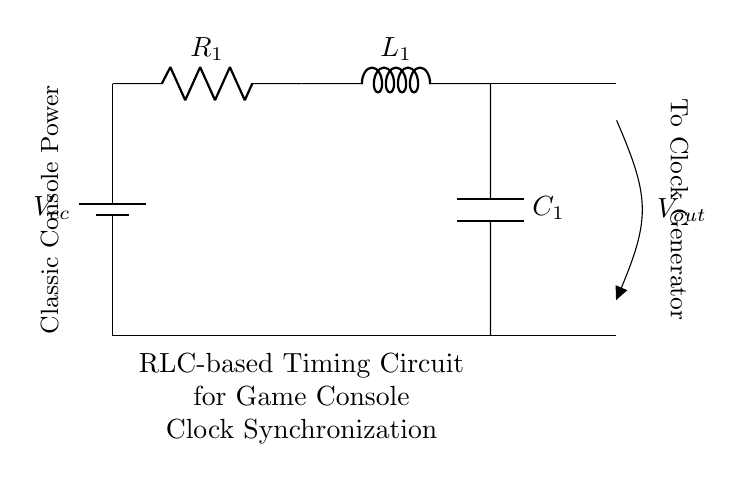What are the components in this circuit? The circuit includes a battery, a resistor, an inductor, and a capacitor, as indicated by the symbols and labels in the diagram.
Answer: battery, resistor, inductor, capacitor What is the value of R1? The value of R1 is not specified in the diagram, so it remains unspecified based on the visual information provided.
Answer: unspecified What is the purpose of the inductor in this circuit? The inductor stores energy in a magnetic field when current flows through it and can influence timing in RLC circuits, contributing to the clock synchronization functionality.
Answer: energy storage What does Vout represent in the circuit? Vout is the output voltage taken across the capacitor, which is essential for clock synchronization in this RLC timing circuit design.
Answer: output voltage What is the relationship between R, L, and C in this timing circuit? In an RLC circuit, R, L, and C work together to determine the time constant and oscillation frequency, which affect how the circuit operates to achieve clock synchronization.
Answer: time constant and frequency What type of circuit is this? This circuit is identified as an RLC circuit since it contains a resistor, an inductor, and a capacitor, specifically arranged for timing functions.
Answer: RLC circuit How does this circuit benefit classic game consoles? This RLC-based timing circuit helps in clock synchronization which is critical for accurate timing in game processes, ensuring smooth gameplay and functionality.
Answer: clock synchronization 